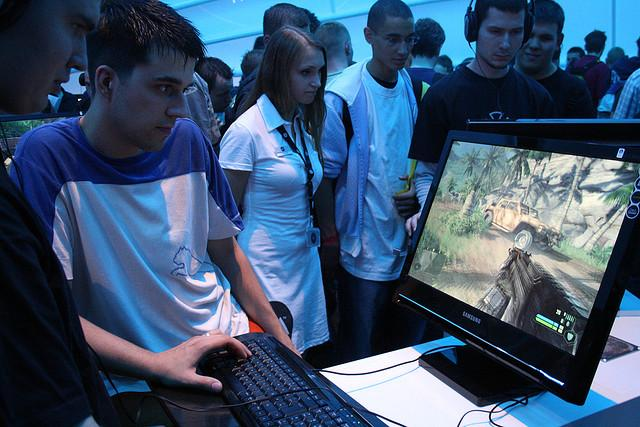What are the two men watching? Please explain your reasoning. video game. The two men are watching a screen showing a video game. 